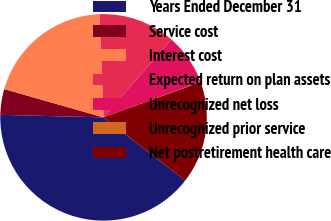Convert chart to OTSL. <chart><loc_0><loc_0><loc_500><loc_500><pie_chart><fcel>Years Ended December 31<fcel>Service cost<fcel>Interest cost<fcel>Expected return on plan assets<fcel>Unrecognized net loss<fcel>Unrecognized prior service<fcel>Net postretirement health care<nl><fcel>39.93%<fcel>4.03%<fcel>19.98%<fcel>12.01%<fcel>8.02%<fcel>0.04%<fcel>16.0%<nl></chart> 